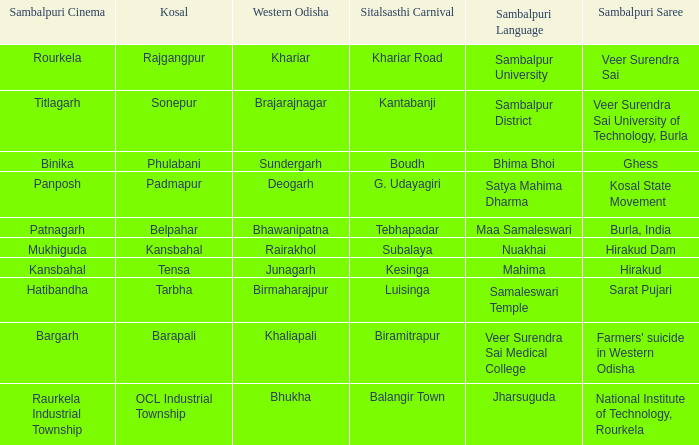What is the sitalsasthi carnival with hirakud as sambalpuri saree? Kesinga. 